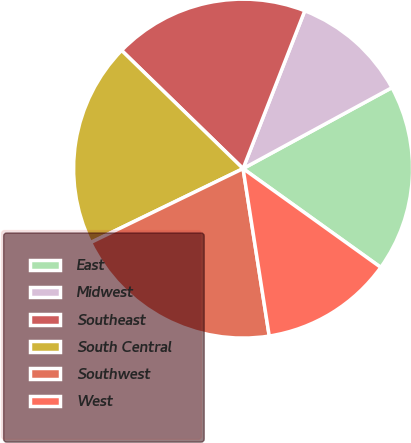Convert chart. <chart><loc_0><loc_0><loc_500><loc_500><pie_chart><fcel>East<fcel>Midwest<fcel>Southeast<fcel>South Central<fcel>Southwest<fcel>West<nl><fcel>17.83%<fcel>11.14%<fcel>18.65%<fcel>19.47%<fcel>20.28%<fcel>12.63%<nl></chart> 